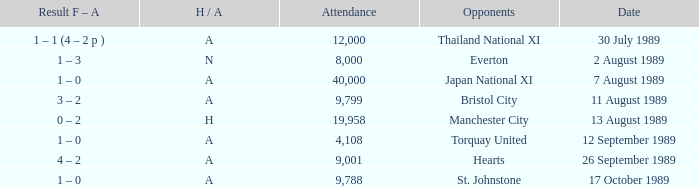How many people attended the match when Manchester United played against the Hearts? 9001.0. 